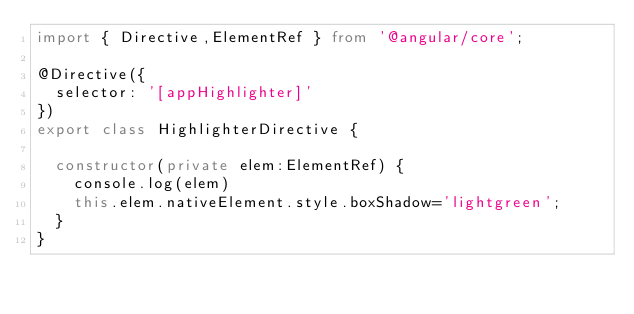Convert code to text. <code><loc_0><loc_0><loc_500><loc_500><_TypeScript_>import { Directive,ElementRef } from '@angular/core';

@Directive({
  selector: '[appHighlighter]'
})
export class HighlighterDirective {

  constructor(private elem:ElementRef) {
    console.log(elem)
    this.elem.nativeElement.style.boxShadow='lightgreen';
  }
}
</code> 